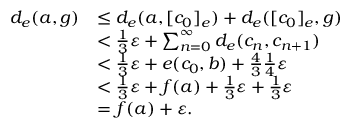<formula> <loc_0><loc_0><loc_500><loc_500>\begin{array} { r l } { d _ { e } ( a , g ) } & { \leq d _ { e } ( a , [ c _ { 0 } ] _ { e } ) + d _ { e } ( [ c _ { 0 } ] _ { e } , g ) } \\ & { < \frac { 1 } { 3 } \varepsilon + \sum _ { n = 0 } ^ { \infty } d _ { e } ( c _ { n } , c _ { n + 1 } ) } \\ & { < \frac { 1 } { 3 } \varepsilon + e ( c _ { 0 } , b ) + \frac { 4 } { 3 } \frac { 1 } { 4 } \varepsilon } \\ & { < \frac { 1 } { 3 } \varepsilon + f ( a ) + \frac { 1 } { 3 } \varepsilon + \frac { 1 } { 3 } \varepsilon } \\ & { = f ( a ) + \varepsilon . } \end{array}</formula> 